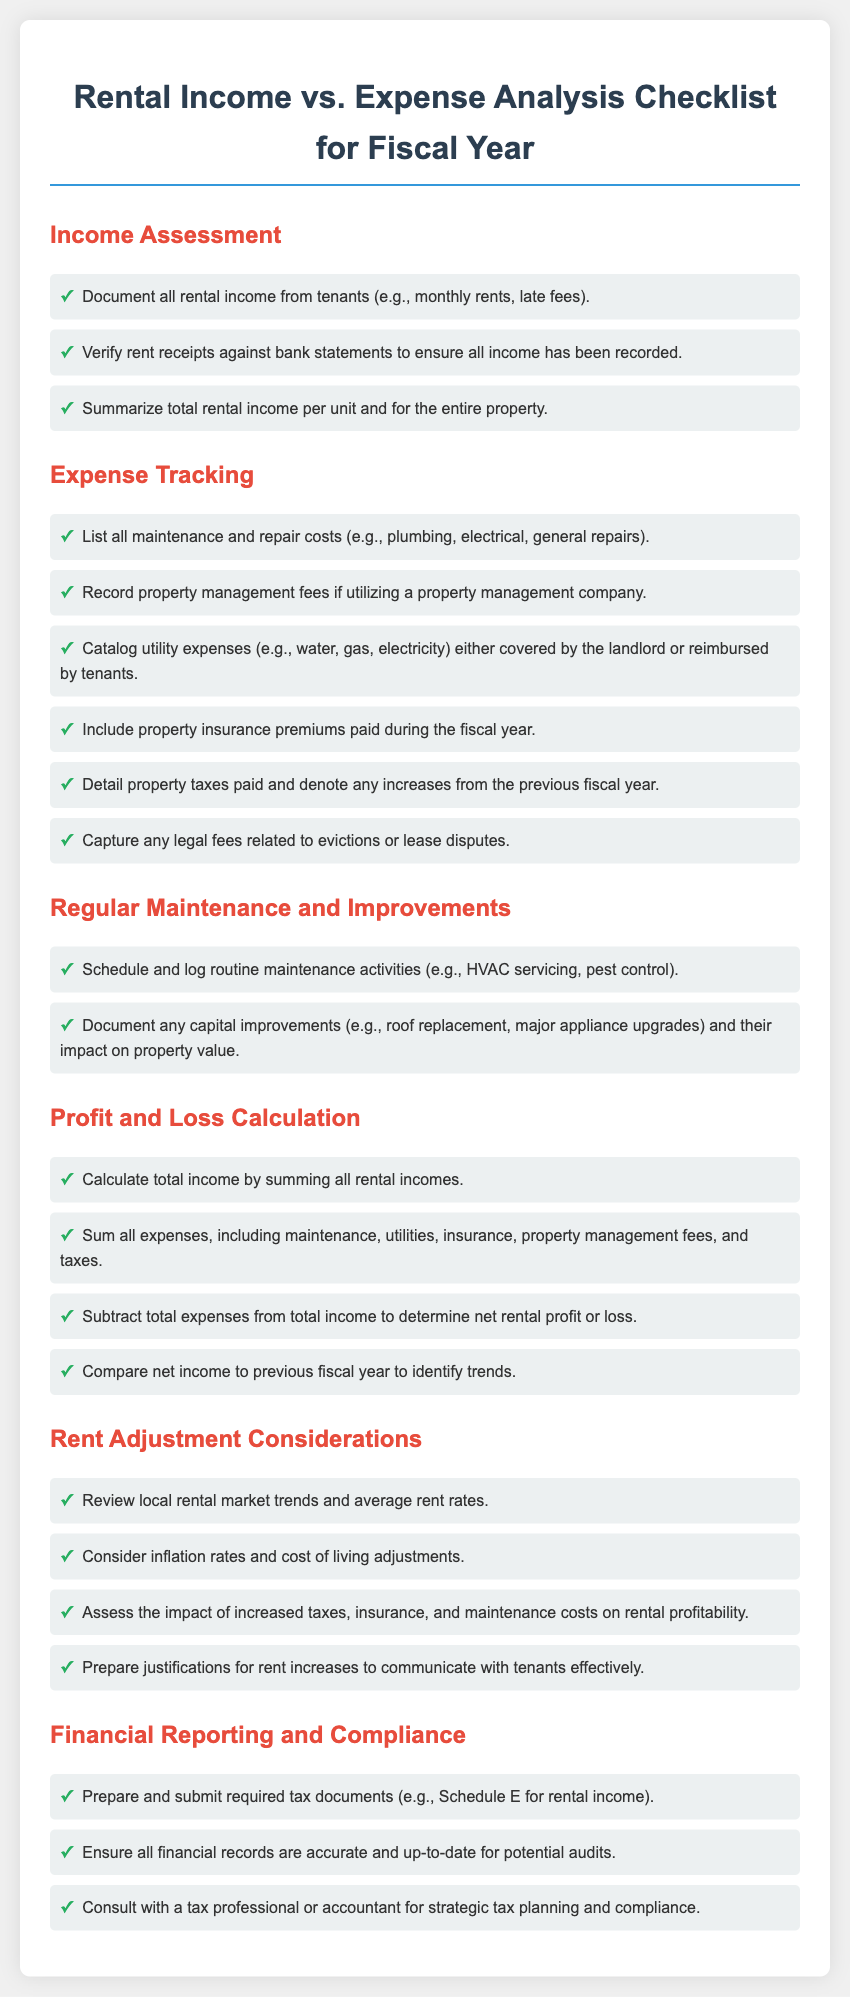What is included in the income assessment? The income assessment lists all rental income sources including monthly rents and late fees.
Answer: rental income from tenants What should be documented under expense tracking? Expense tracking includes maintenance costs, property management fees, utility expenses, insurance premiums, property taxes, and legal fees.
Answer: all maintenance and repair costs What is one type of regular maintenance activity to log? Regular maintenance activities include HVAC servicing and pest control.
Answer: HVAC servicing How do you determine net rental profit or loss? Net rental profit or loss is calculated by subtracting total expenses from total income.
Answer: subtract total expenses from total income What should be reviewed for rent adjustment considerations? Rent adjustment considerations include local rental market trends and average rent rates.
Answer: local rental market trends What is the purpose of preparing and submitting required tax documents? The purpose is to ensure compliance and proper reporting of rental income for tax purposes.
Answer: compliance and proper reporting What impact should be recorded regarding capital improvements? The impact of capital improvements on property value should be documented.
Answer: impact on property value What type of fees should be included under expense tracking? Property management fees, if utilized, should be recorded.
Answer: property management fees What is needed for financial reporting and compliance? Accurate and up-to-date financial records are required for potential audits.
Answer: accurate and up-to-date financial records 